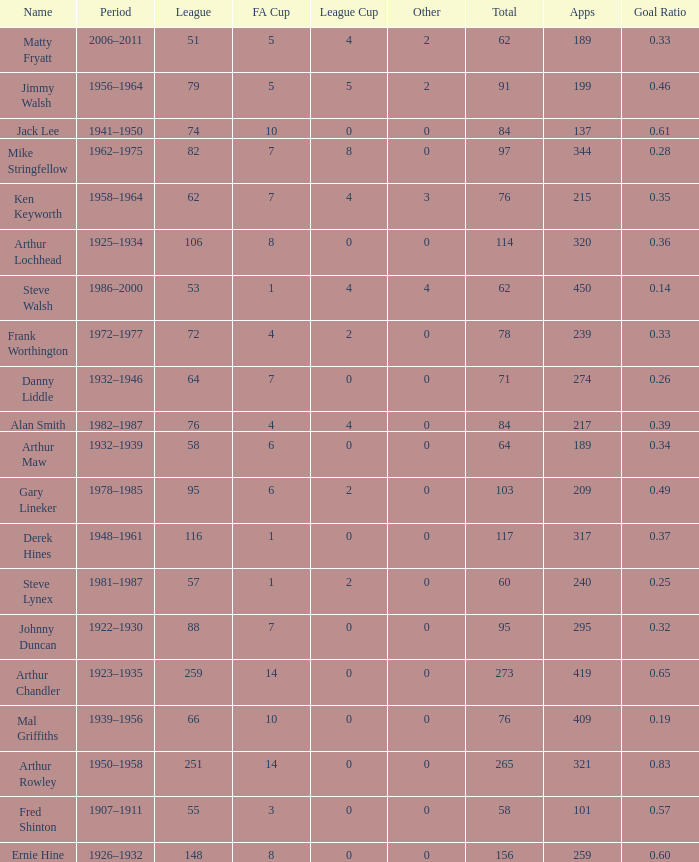Help me parse the entirety of this table. {'header': ['Name', 'Period', 'League', 'FA Cup', 'League Cup', 'Other', 'Total', 'Apps', 'Goal Ratio'], 'rows': [['Matty Fryatt', '2006–2011', '51', '5', '4', '2', '62', '189', '0.33'], ['Jimmy Walsh', '1956–1964', '79', '5', '5', '2', '91', '199', '0.46'], ['Jack Lee', '1941–1950', '74', '10', '0', '0', '84', '137', '0.61'], ['Mike Stringfellow', '1962–1975', '82', '7', '8', '0', '97', '344', '0.28'], ['Ken Keyworth', '1958–1964', '62', '7', '4', '3', '76', '215', '0.35'], ['Arthur Lochhead', '1925–1934', '106', '8', '0', '0', '114', '320', '0.36'], ['Steve Walsh', '1986–2000', '53', '1', '4', '4', '62', '450', '0.14'], ['Frank Worthington', '1972–1977', '72', '4', '2', '0', '78', '239', '0.33'], ['Danny Liddle', '1932–1946', '64', '7', '0', '0', '71', '274', '0.26'], ['Alan Smith', '1982–1987', '76', '4', '4', '0', '84', '217', '0.39'], ['Arthur Maw', '1932–1939', '58', '6', '0', '0', '64', '189', '0.34'], ['Gary Lineker', '1978–1985', '95', '6', '2', '0', '103', '209', '0.49'], ['Derek Hines', '1948–1961', '116', '1', '0', '0', '117', '317', '0.37'], ['Steve Lynex', '1981–1987', '57', '1', '2', '0', '60', '240', '0.25'], ['Johnny Duncan', '1922–1930', '88', '7', '0', '0', '95', '295', '0.32'], ['Arthur Chandler', '1923–1935', '259', '14', '0', '0', '273', '419', '0.65'], ['Mal Griffiths', '1939–1956', '66', '10', '0', '0', '76', '409', '0.19'], ['Arthur Rowley', '1950–1958', '251', '14', '0', '0', '265', '321', '0.83'], ['Fred Shinton', '1907–1911', '55', '3', '0', '0', '58', '101', '0.57'], ['Ernie Hine', '1926–1932', '148', '8', '0', '0', '156', '259', '0.60']]} What's the highest FA Cup with the Name of Alan Smith, and League Cup smaller than 4? None. 